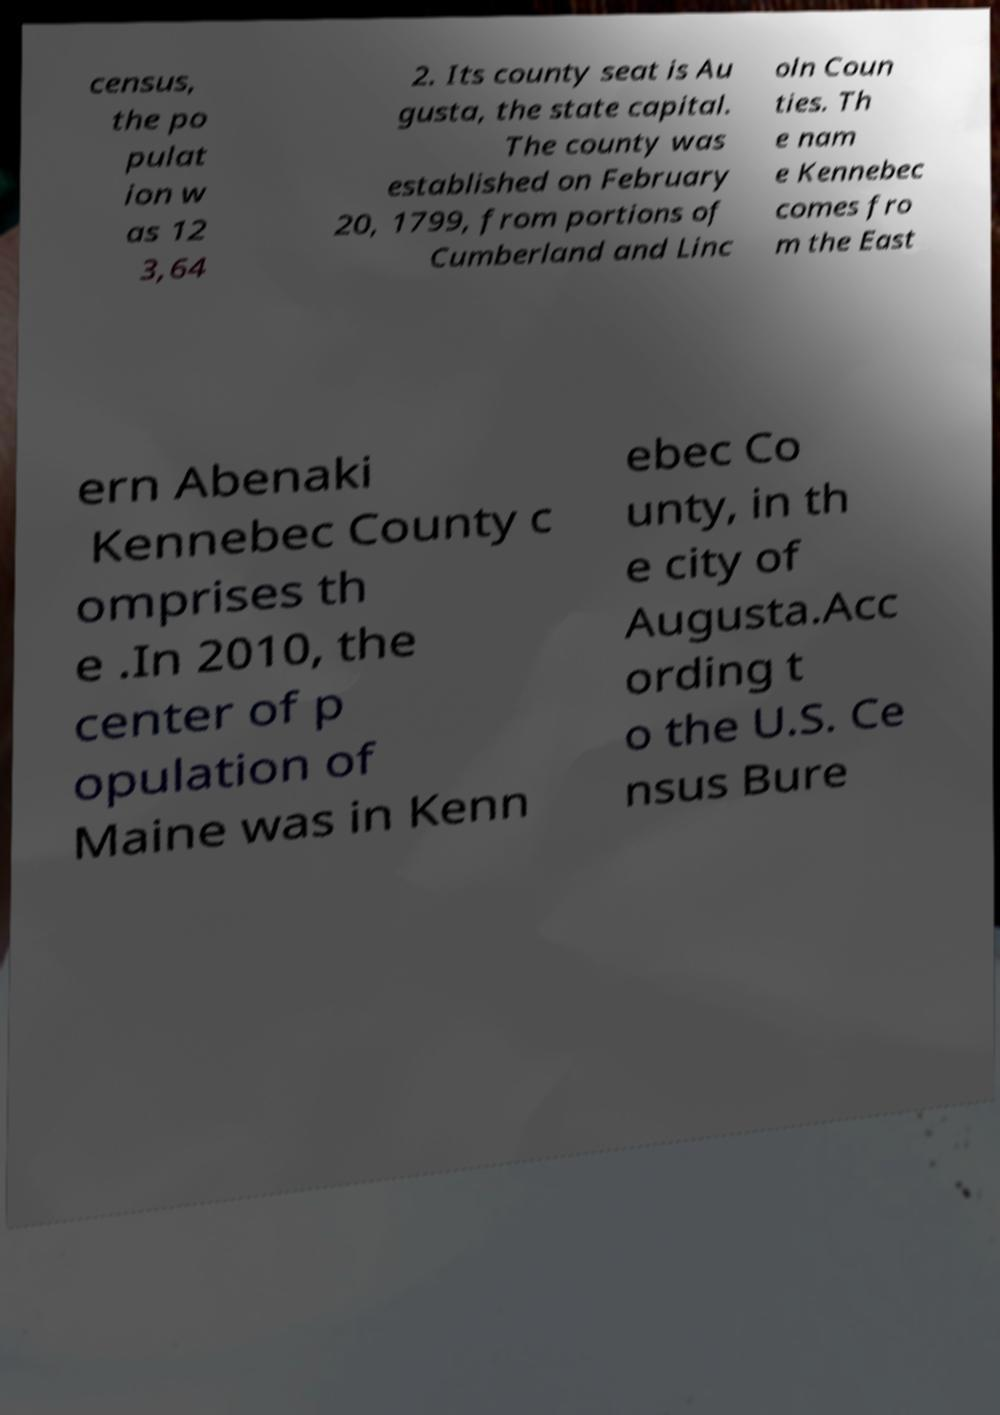Please identify and transcribe the text found in this image. census, the po pulat ion w as 12 3,64 2. Its county seat is Au gusta, the state capital. The county was established on February 20, 1799, from portions of Cumberland and Linc oln Coun ties. Th e nam e Kennebec comes fro m the East ern Abenaki Kennebec County c omprises th e .In 2010, the center of p opulation of Maine was in Kenn ebec Co unty, in th e city of Augusta.Acc ording t o the U.S. Ce nsus Bure 